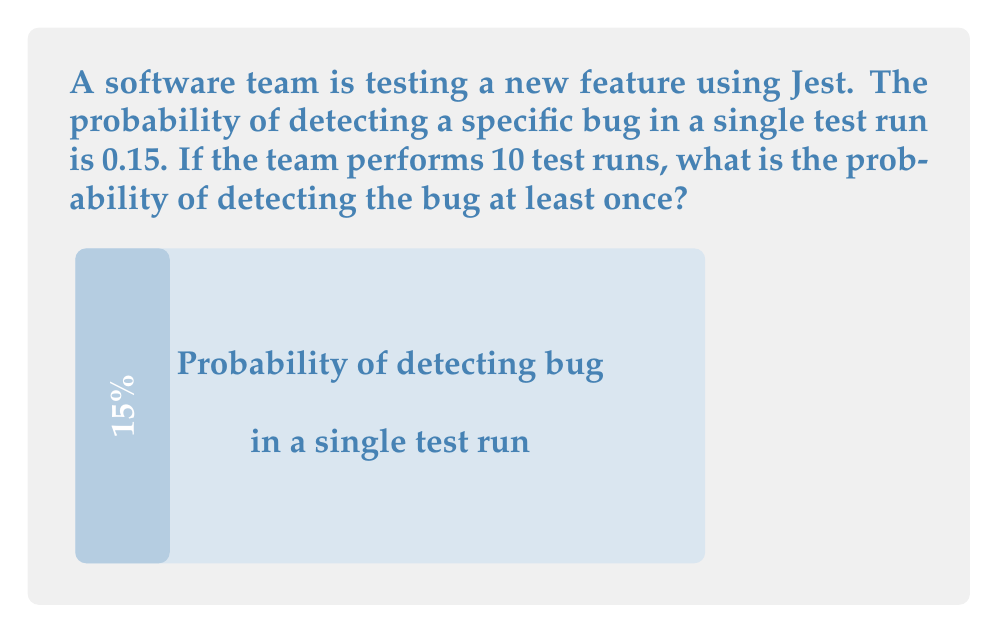Help me with this question. Let's approach this step-by-step:

1) First, let's consider the probability of not detecting the bug in a single test run:
   $P(\text{not detecting}) = 1 - P(\text{detecting}) = 1 - 0.15 = 0.85$

2) For the bug to not be detected in 10 test runs, it must not be detected in each individual run. Since the runs are independent, we multiply these probabilities:
   $P(\text{not detecting in 10 runs}) = 0.85^{10}$

3) Now, the probability of detecting the bug at least once is the complement of not detecting it at all:
   $P(\text{detecting at least once}) = 1 - P(\text{not detecting in 10 runs})$

4) Let's calculate this:
   $P(\text{detecting at least once}) = 1 - 0.85^{10}$

5) Using a calculator or computer:
   $1 - 0.85^{10} \approx 1 - 0.1968 = 0.8032$

6) Converting to a percentage:
   $0.8032 \times 100\% = 80.32\%$

This means there's about an 80.32% chance of detecting the bug at least once in 10 test runs.
Answer: $80.32\%$ 